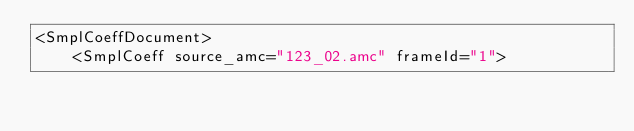<code> <loc_0><loc_0><loc_500><loc_500><_XML_><SmplCoeffDocument>
    <SmplCoeff source_amc="123_02.amc" frameId="1"></code> 